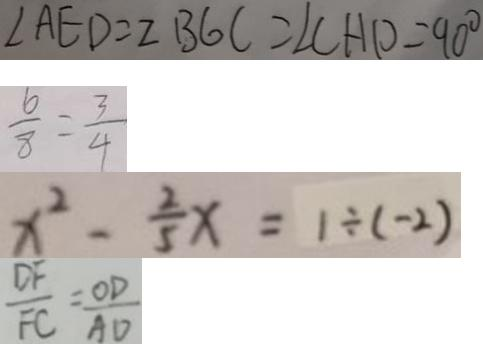Convert formula to latex. <formula><loc_0><loc_0><loc_500><loc_500>\angle A E D = 2 B G C = \angle C H P = 9 0 ^ { \circ } 
 \frac { 6 } { 8 } = \frac { 3 } { 4 } 
 x ^ { 2 } - \frac { 2 } { 5 } x = 1 \div ( - 2 ) 
 \frac { D F } { F C } = \frac { O D } { A D }</formula> 